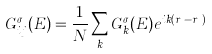Convert formula to latex. <formula><loc_0><loc_0><loc_500><loc_500>G ^ { \sigma } _ { i j } ( E ) = \frac { 1 } { N } \sum _ { k } G ^ { \sigma } _ { k } ( E ) e ^ { i k ( r _ { i } - r _ { j } ) }</formula> 